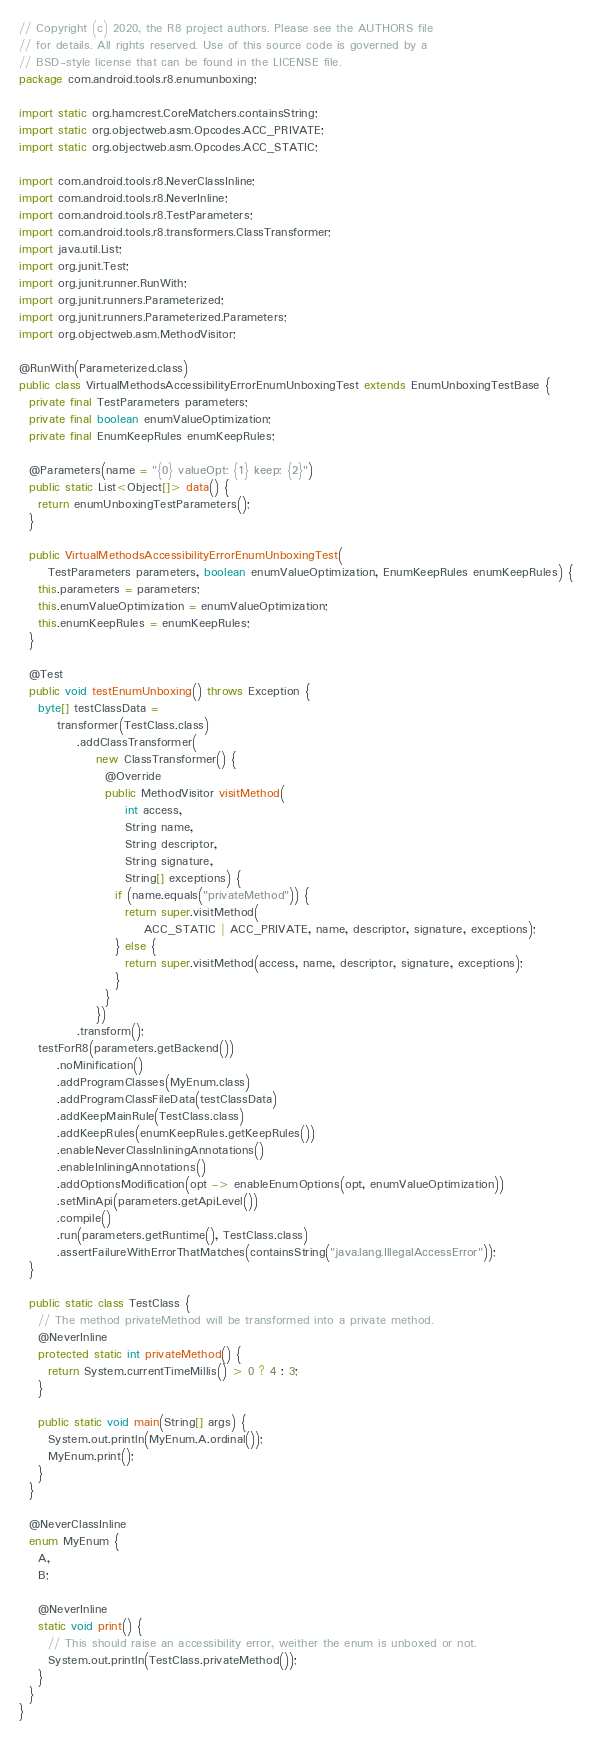Convert code to text. <code><loc_0><loc_0><loc_500><loc_500><_Java_>// Copyright (c) 2020, the R8 project authors. Please see the AUTHORS file
// for details. All rights reserved. Use of this source code is governed by a
// BSD-style license that can be found in the LICENSE file.
package com.android.tools.r8.enumunboxing;

import static org.hamcrest.CoreMatchers.containsString;
import static org.objectweb.asm.Opcodes.ACC_PRIVATE;
import static org.objectweb.asm.Opcodes.ACC_STATIC;

import com.android.tools.r8.NeverClassInline;
import com.android.tools.r8.NeverInline;
import com.android.tools.r8.TestParameters;
import com.android.tools.r8.transformers.ClassTransformer;
import java.util.List;
import org.junit.Test;
import org.junit.runner.RunWith;
import org.junit.runners.Parameterized;
import org.junit.runners.Parameterized.Parameters;
import org.objectweb.asm.MethodVisitor;

@RunWith(Parameterized.class)
public class VirtualMethodsAccessibilityErrorEnumUnboxingTest extends EnumUnboxingTestBase {
  private final TestParameters parameters;
  private final boolean enumValueOptimization;
  private final EnumKeepRules enumKeepRules;

  @Parameters(name = "{0} valueOpt: {1} keep: {2}")
  public static List<Object[]> data() {
    return enumUnboxingTestParameters();
  }

  public VirtualMethodsAccessibilityErrorEnumUnboxingTest(
      TestParameters parameters, boolean enumValueOptimization, EnumKeepRules enumKeepRules) {
    this.parameters = parameters;
    this.enumValueOptimization = enumValueOptimization;
    this.enumKeepRules = enumKeepRules;
  }

  @Test
  public void testEnumUnboxing() throws Exception {
    byte[] testClassData =
        transformer(TestClass.class)
            .addClassTransformer(
                new ClassTransformer() {
                  @Override
                  public MethodVisitor visitMethod(
                      int access,
                      String name,
                      String descriptor,
                      String signature,
                      String[] exceptions) {
                    if (name.equals("privateMethod")) {
                      return super.visitMethod(
                          ACC_STATIC | ACC_PRIVATE, name, descriptor, signature, exceptions);
                    } else {
                      return super.visitMethod(access, name, descriptor, signature, exceptions);
                    }
                  }
                })
            .transform();
    testForR8(parameters.getBackend())
        .noMinification()
        .addProgramClasses(MyEnum.class)
        .addProgramClassFileData(testClassData)
        .addKeepMainRule(TestClass.class)
        .addKeepRules(enumKeepRules.getKeepRules())
        .enableNeverClassInliningAnnotations()
        .enableInliningAnnotations()
        .addOptionsModification(opt -> enableEnumOptions(opt, enumValueOptimization))
        .setMinApi(parameters.getApiLevel())
        .compile()
        .run(parameters.getRuntime(), TestClass.class)
        .assertFailureWithErrorThatMatches(containsString("java.lang.IllegalAccessError"));
  }

  public static class TestClass {
    // The method privateMethod will be transformed into a private method.
    @NeverInline
    protected static int privateMethod() {
      return System.currentTimeMillis() > 0 ? 4 : 3;
    }

    public static void main(String[] args) {
      System.out.println(MyEnum.A.ordinal());
      MyEnum.print();
    }
  }

  @NeverClassInline
  enum MyEnum {
    A,
    B;

    @NeverInline
    static void print() {
      // This should raise an accessibility error, weither the enum is unboxed or not.
      System.out.println(TestClass.privateMethod());
    }
  }
}
</code> 